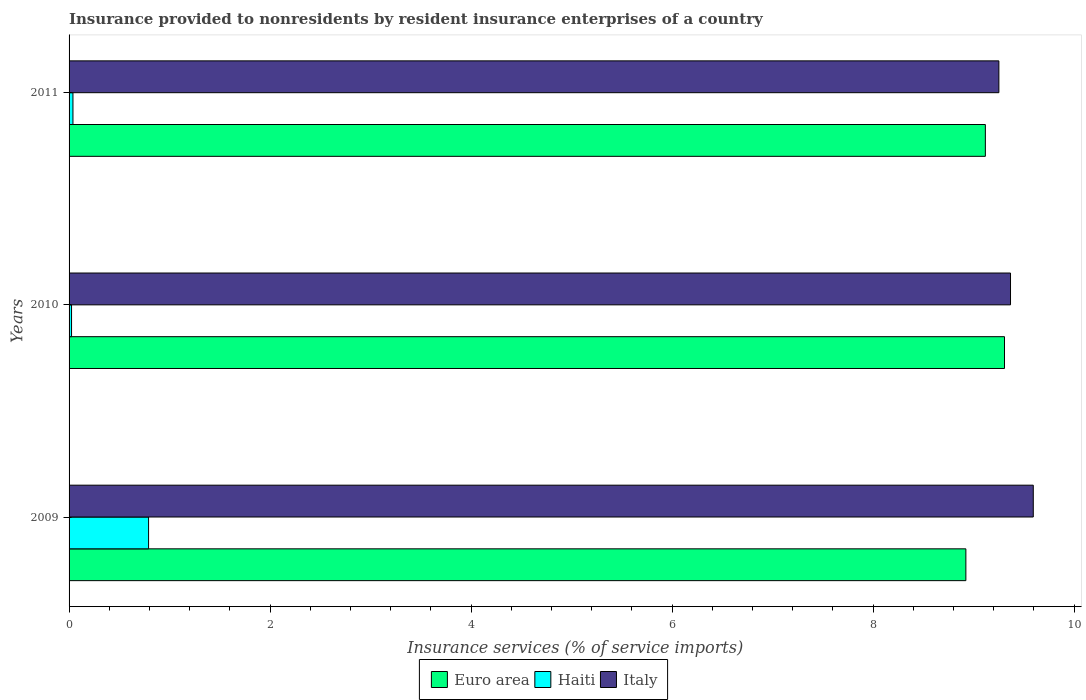How many different coloured bars are there?
Offer a terse response. 3. How many groups of bars are there?
Provide a succinct answer. 3. How many bars are there on the 2nd tick from the top?
Give a very brief answer. 3. What is the label of the 2nd group of bars from the top?
Your answer should be compact. 2010. What is the insurance provided to nonresidents in Haiti in 2010?
Give a very brief answer. 0.02. Across all years, what is the maximum insurance provided to nonresidents in Italy?
Provide a succinct answer. 9.59. Across all years, what is the minimum insurance provided to nonresidents in Euro area?
Provide a succinct answer. 8.92. In which year was the insurance provided to nonresidents in Euro area maximum?
Give a very brief answer. 2010. What is the total insurance provided to nonresidents in Italy in the graph?
Ensure brevity in your answer.  28.21. What is the difference between the insurance provided to nonresidents in Italy in 2009 and that in 2010?
Provide a succinct answer. 0.23. What is the difference between the insurance provided to nonresidents in Haiti in 2009 and the insurance provided to nonresidents in Euro area in 2011?
Keep it short and to the point. -8.33. What is the average insurance provided to nonresidents in Euro area per year?
Offer a very short reply. 9.12. In the year 2009, what is the difference between the insurance provided to nonresidents in Euro area and insurance provided to nonresidents in Italy?
Provide a short and direct response. -0.67. In how many years, is the insurance provided to nonresidents in Euro area greater than 6.8 %?
Your answer should be very brief. 3. What is the ratio of the insurance provided to nonresidents in Euro area in 2009 to that in 2011?
Your answer should be very brief. 0.98. Is the difference between the insurance provided to nonresidents in Euro area in 2009 and 2010 greater than the difference between the insurance provided to nonresidents in Italy in 2009 and 2010?
Offer a very short reply. No. What is the difference between the highest and the second highest insurance provided to nonresidents in Euro area?
Your answer should be very brief. 0.19. What is the difference between the highest and the lowest insurance provided to nonresidents in Italy?
Give a very brief answer. 0.34. What does the 2nd bar from the top in 2011 represents?
Your answer should be very brief. Haiti. Is it the case that in every year, the sum of the insurance provided to nonresidents in Haiti and insurance provided to nonresidents in Italy is greater than the insurance provided to nonresidents in Euro area?
Offer a terse response. Yes. How many years are there in the graph?
Provide a short and direct response. 3. Does the graph contain any zero values?
Provide a succinct answer. No. Does the graph contain grids?
Keep it short and to the point. No. Where does the legend appear in the graph?
Give a very brief answer. Bottom center. How many legend labels are there?
Offer a terse response. 3. How are the legend labels stacked?
Make the answer very short. Horizontal. What is the title of the graph?
Provide a short and direct response. Insurance provided to nonresidents by resident insurance enterprises of a country. What is the label or title of the X-axis?
Provide a succinct answer. Insurance services (% of service imports). What is the label or title of the Y-axis?
Provide a short and direct response. Years. What is the Insurance services (% of service imports) of Euro area in 2009?
Your response must be concise. 8.92. What is the Insurance services (% of service imports) in Haiti in 2009?
Offer a very short reply. 0.79. What is the Insurance services (% of service imports) of Italy in 2009?
Your response must be concise. 9.59. What is the Insurance services (% of service imports) of Euro area in 2010?
Your answer should be very brief. 9.31. What is the Insurance services (% of service imports) in Haiti in 2010?
Your answer should be compact. 0.02. What is the Insurance services (% of service imports) of Italy in 2010?
Ensure brevity in your answer.  9.37. What is the Insurance services (% of service imports) of Euro area in 2011?
Your response must be concise. 9.12. What is the Insurance services (% of service imports) of Haiti in 2011?
Provide a succinct answer. 0.04. What is the Insurance services (% of service imports) in Italy in 2011?
Make the answer very short. 9.25. Across all years, what is the maximum Insurance services (% of service imports) in Euro area?
Give a very brief answer. 9.31. Across all years, what is the maximum Insurance services (% of service imports) of Haiti?
Ensure brevity in your answer.  0.79. Across all years, what is the maximum Insurance services (% of service imports) of Italy?
Provide a short and direct response. 9.59. Across all years, what is the minimum Insurance services (% of service imports) of Euro area?
Your response must be concise. 8.92. Across all years, what is the minimum Insurance services (% of service imports) of Haiti?
Give a very brief answer. 0.02. Across all years, what is the minimum Insurance services (% of service imports) of Italy?
Give a very brief answer. 9.25. What is the total Insurance services (% of service imports) in Euro area in the graph?
Your response must be concise. 27.35. What is the total Insurance services (% of service imports) in Haiti in the graph?
Give a very brief answer. 0.85. What is the total Insurance services (% of service imports) of Italy in the graph?
Your response must be concise. 28.21. What is the difference between the Insurance services (% of service imports) of Euro area in 2009 and that in 2010?
Provide a succinct answer. -0.38. What is the difference between the Insurance services (% of service imports) in Haiti in 2009 and that in 2010?
Provide a short and direct response. 0.77. What is the difference between the Insurance services (% of service imports) in Italy in 2009 and that in 2010?
Offer a very short reply. 0.23. What is the difference between the Insurance services (% of service imports) in Euro area in 2009 and that in 2011?
Your answer should be compact. -0.19. What is the difference between the Insurance services (% of service imports) of Haiti in 2009 and that in 2011?
Provide a succinct answer. 0.75. What is the difference between the Insurance services (% of service imports) in Italy in 2009 and that in 2011?
Your answer should be compact. 0.34. What is the difference between the Insurance services (% of service imports) in Euro area in 2010 and that in 2011?
Your answer should be very brief. 0.19. What is the difference between the Insurance services (% of service imports) in Haiti in 2010 and that in 2011?
Ensure brevity in your answer.  -0.01. What is the difference between the Insurance services (% of service imports) in Italy in 2010 and that in 2011?
Ensure brevity in your answer.  0.12. What is the difference between the Insurance services (% of service imports) of Euro area in 2009 and the Insurance services (% of service imports) of Haiti in 2010?
Your answer should be compact. 8.9. What is the difference between the Insurance services (% of service imports) of Euro area in 2009 and the Insurance services (% of service imports) of Italy in 2010?
Offer a very short reply. -0.44. What is the difference between the Insurance services (% of service imports) of Haiti in 2009 and the Insurance services (% of service imports) of Italy in 2010?
Provide a short and direct response. -8.58. What is the difference between the Insurance services (% of service imports) of Euro area in 2009 and the Insurance services (% of service imports) of Haiti in 2011?
Your answer should be very brief. 8.88. What is the difference between the Insurance services (% of service imports) in Euro area in 2009 and the Insurance services (% of service imports) in Italy in 2011?
Keep it short and to the point. -0.33. What is the difference between the Insurance services (% of service imports) in Haiti in 2009 and the Insurance services (% of service imports) in Italy in 2011?
Your answer should be very brief. -8.46. What is the difference between the Insurance services (% of service imports) in Euro area in 2010 and the Insurance services (% of service imports) in Haiti in 2011?
Give a very brief answer. 9.27. What is the difference between the Insurance services (% of service imports) of Euro area in 2010 and the Insurance services (% of service imports) of Italy in 2011?
Keep it short and to the point. 0.06. What is the difference between the Insurance services (% of service imports) of Haiti in 2010 and the Insurance services (% of service imports) of Italy in 2011?
Provide a short and direct response. -9.23. What is the average Insurance services (% of service imports) of Euro area per year?
Your answer should be compact. 9.12. What is the average Insurance services (% of service imports) in Haiti per year?
Provide a short and direct response. 0.28. What is the average Insurance services (% of service imports) in Italy per year?
Keep it short and to the point. 9.4. In the year 2009, what is the difference between the Insurance services (% of service imports) in Euro area and Insurance services (% of service imports) in Haiti?
Your answer should be compact. 8.13. In the year 2009, what is the difference between the Insurance services (% of service imports) of Euro area and Insurance services (% of service imports) of Italy?
Give a very brief answer. -0.67. In the year 2009, what is the difference between the Insurance services (% of service imports) of Haiti and Insurance services (% of service imports) of Italy?
Your answer should be compact. -8.8. In the year 2010, what is the difference between the Insurance services (% of service imports) of Euro area and Insurance services (% of service imports) of Haiti?
Your answer should be very brief. 9.28. In the year 2010, what is the difference between the Insurance services (% of service imports) in Euro area and Insurance services (% of service imports) in Italy?
Provide a succinct answer. -0.06. In the year 2010, what is the difference between the Insurance services (% of service imports) in Haiti and Insurance services (% of service imports) in Italy?
Offer a terse response. -9.34. In the year 2011, what is the difference between the Insurance services (% of service imports) in Euro area and Insurance services (% of service imports) in Haiti?
Provide a short and direct response. 9.08. In the year 2011, what is the difference between the Insurance services (% of service imports) of Euro area and Insurance services (% of service imports) of Italy?
Ensure brevity in your answer.  -0.13. In the year 2011, what is the difference between the Insurance services (% of service imports) in Haiti and Insurance services (% of service imports) in Italy?
Provide a succinct answer. -9.21. What is the ratio of the Insurance services (% of service imports) in Euro area in 2009 to that in 2010?
Offer a terse response. 0.96. What is the ratio of the Insurance services (% of service imports) of Haiti in 2009 to that in 2010?
Keep it short and to the point. 32.19. What is the ratio of the Insurance services (% of service imports) in Italy in 2009 to that in 2010?
Keep it short and to the point. 1.02. What is the ratio of the Insurance services (% of service imports) in Euro area in 2009 to that in 2011?
Make the answer very short. 0.98. What is the ratio of the Insurance services (% of service imports) in Haiti in 2009 to that in 2011?
Ensure brevity in your answer.  20.45. What is the ratio of the Insurance services (% of service imports) in Italy in 2009 to that in 2011?
Ensure brevity in your answer.  1.04. What is the ratio of the Insurance services (% of service imports) in Euro area in 2010 to that in 2011?
Ensure brevity in your answer.  1.02. What is the ratio of the Insurance services (% of service imports) in Haiti in 2010 to that in 2011?
Your answer should be compact. 0.64. What is the ratio of the Insurance services (% of service imports) of Italy in 2010 to that in 2011?
Make the answer very short. 1.01. What is the difference between the highest and the second highest Insurance services (% of service imports) in Euro area?
Offer a terse response. 0.19. What is the difference between the highest and the second highest Insurance services (% of service imports) in Haiti?
Your answer should be compact. 0.75. What is the difference between the highest and the second highest Insurance services (% of service imports) of Italy?
Provide a short and direct response. 0.23. What is the difference between the highest and the lowest Insurance services (% of service imports) in Euro area?
Ensure brevity in your answer.  0.38. What is the difference between the highest and the lowest Insurance services (% of service imports) of Haiti?
Your response must be concise. 0.77. What is the difference between the highest and the lowest Insurance services (% of service imports) of Italy?
Offer a terse response. 0.34. 